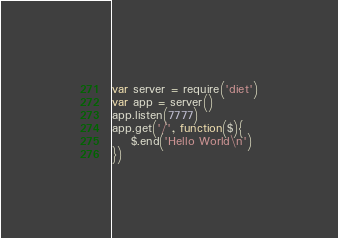<code> <loc_0><loc_0><loc_500><loc_500><_JavaScript_>var server = require('diet')
var app = server()
app.listen(7777)
app.get('/', function($){ 
	$.end('Hello World\n') 
})</code> 